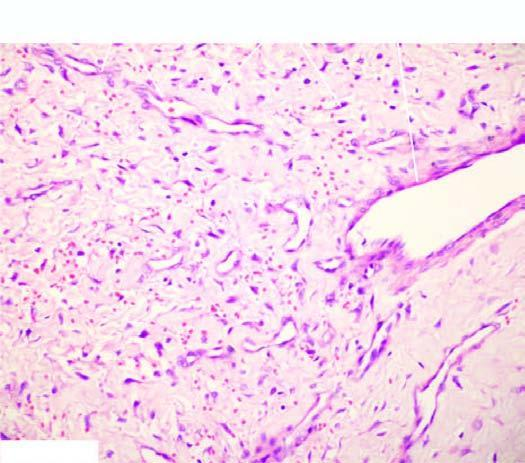what are variable-sized?
Answer the question using a single word or phrase. Blood vessels 